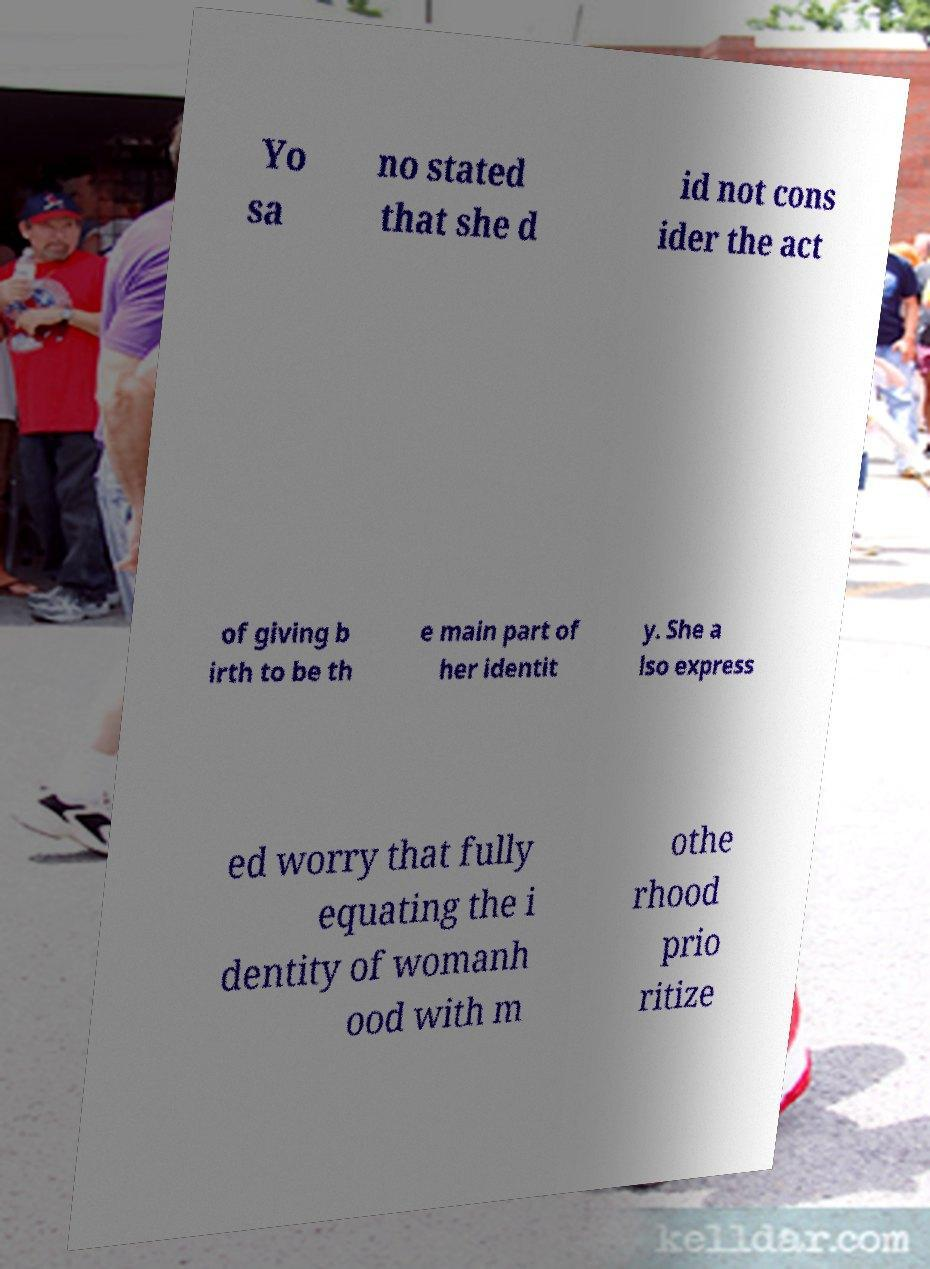Can you accurately transcribe the text from the provided image for me? Yo sa no stated that she d id not cons ider the act of giving b irth to be th e main part of her identit y. She a lso express ed worry that fully equating the i dentity of womanh ood with m othe rhood prio ritize 